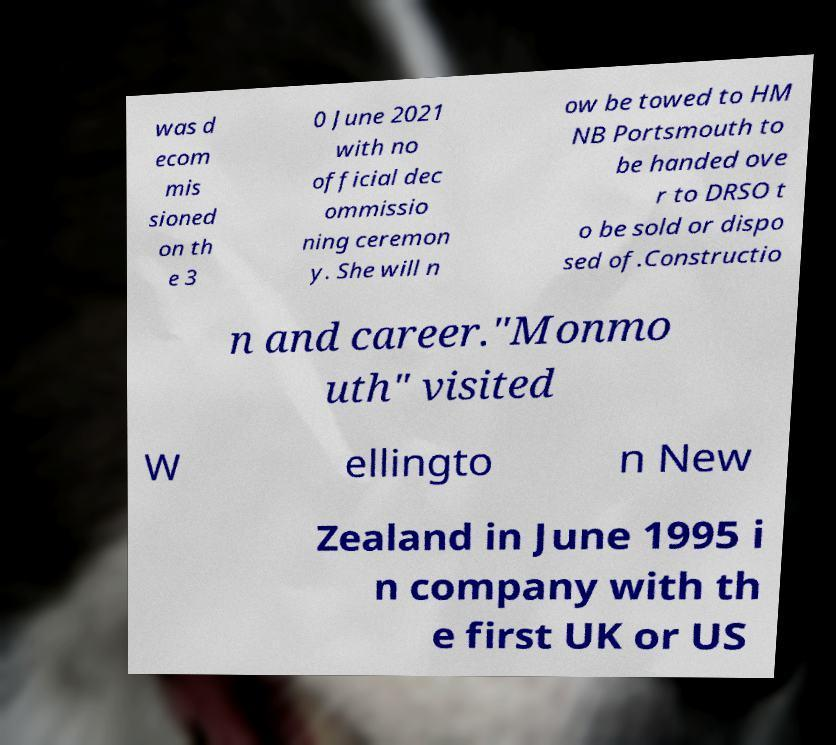What messages or text are displayed in this image? I need them in a readable, typed format. was d ecom mis sioned on th e 3 0 June 2021 with no official dec ommissio ning ceremon y. She will n ow be towed to HM NB Portsmouth to be handed ove r to DRSO t o be sold or dispo sed of.Constructio n and career."Monmo uth" visited W ellingto n New Zealand in June 1995 i n company with th e first UK or US 